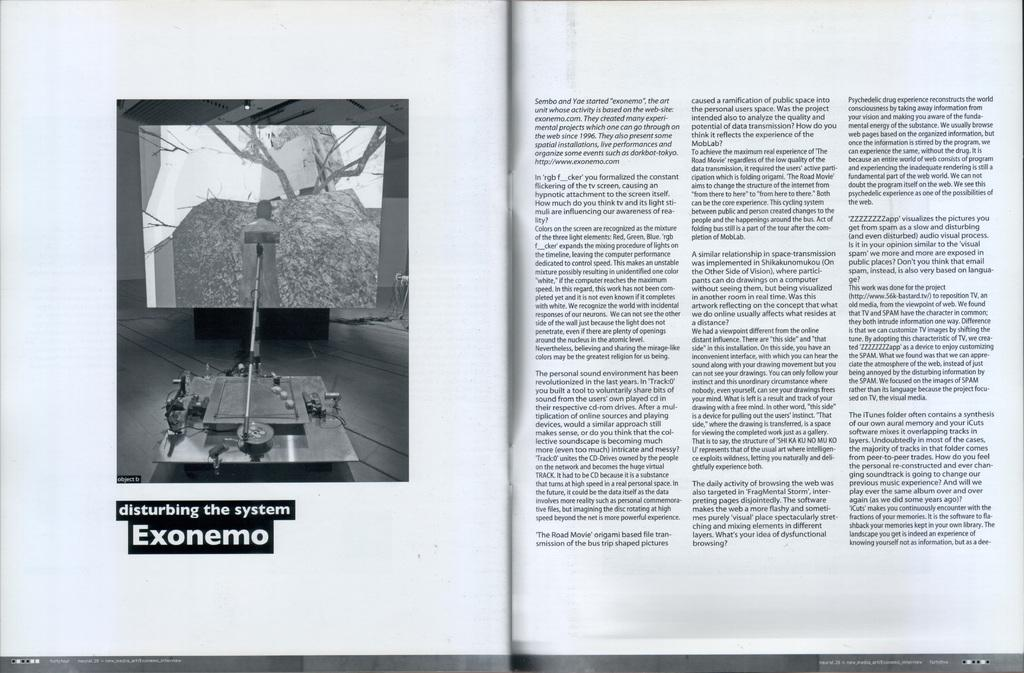What is the main subject of the image? The main subject of the image is a page. What can be found on the page? The page contains text. Can you tell me how many tigers are depicted on the page? There are no tigers depicted on the page; it contains text only. What type of verse can be found on the page? There is no verse present on the page; it contains text, but we cannot determine the type of text without more information. 